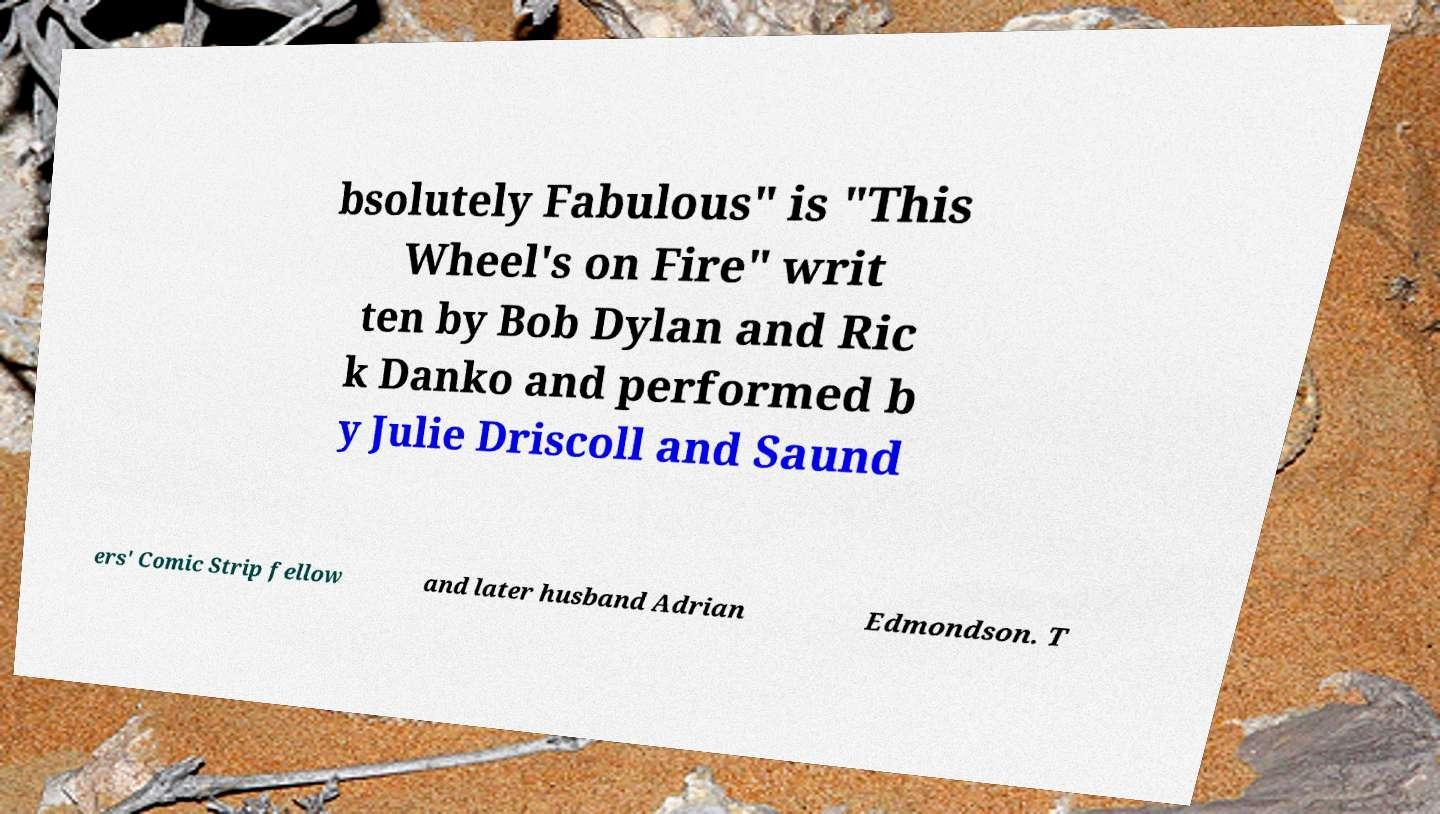I need the written content from this picture converted into text. Can you do that? bsolutely Fabulous" is "This Wheel's on Fire" writ ten by Bob Dylan and Ric k Danko and performed b y Julie Driscoll and Saund ers' Comic Strip fellow and later husband Adrian Edmondson. T 